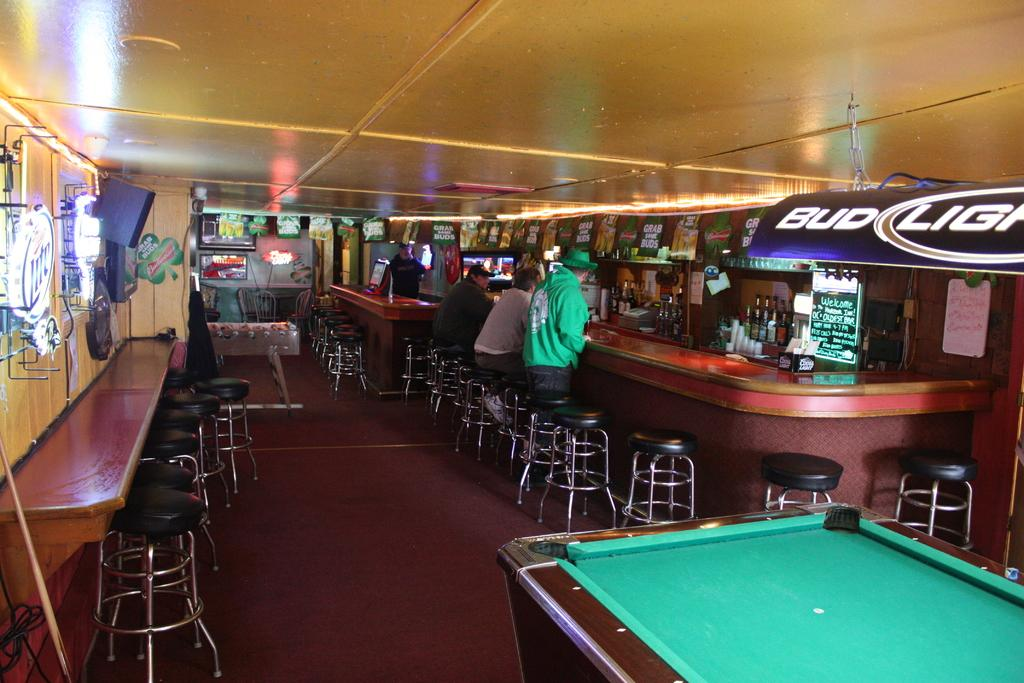What type of furniture is present in the image? There is a table and chairs in the image. What type of beverages can be seen in the image? There are wine bottles in the image. What type of game can be played in the room? There is a snooker table in the image, which suggests that snooker can be played. What type of lighting is present in the image? There are lights in the image. What type of parcel is being delivered to the room in the image? There is no parcel being delivered in the image; it only shows a table, chairs, wine bottles, a snooker table, and lights. 